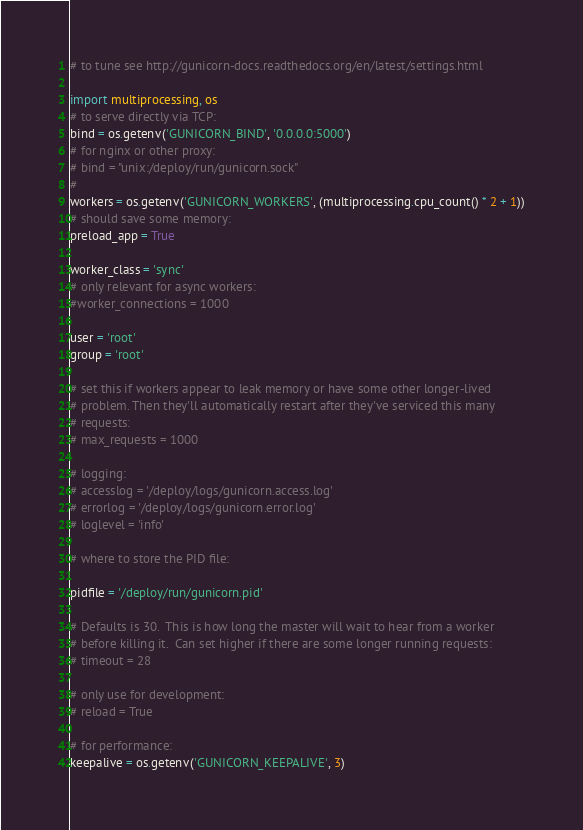<code> <loc_0><loc_0><loc_500><loc_500><_Python_># to tune see http://gunicorn-docs.readthedocs.org/en/latest/settings.html

import multiprocessing, os
# to serve directly via TCP:
bind = os.getenv('GUNICORN_BIND', '0.0.0.0:5000')
# for nginx or other proxy:
# bind = "unix:/deploy/run/gunicorn.sock"
#
workers = os.getenv('GUNICORN_WORKERS', (multiprocessing.cpu_count() * 2 + 1))
# should save some memory:
preload_app = True

worker_class = 'sync'
# only relevant for async workers:
#worker_connections = 1000

user = 'root'
group = 'root'

# set this if workers appear to leak memory or have some other longer-lived
# problem. Then they'll automatically restart after they've serviced this many
# requests:
# max_requests = 1000

# logging:
# accesslog = '/deploy/logs/gunicorn.access.log'
# errorlog = '/deploy/logs/gunicorn.error.log'
# loglevel = 'info'

# where to store the PID file:

pidfile = '/deploy/run/gunicorn.pid'

# Defaults is 30.  This is how long the master will wait to hear from a worker
# before killing it.  Can set higher if there are some longer running requests:
# timeout = 28

# only use for development:
# reload = True

# for performance:
keepalive = os.getenv('GUNICORN_KEEPALIVE', 3)
</code> 